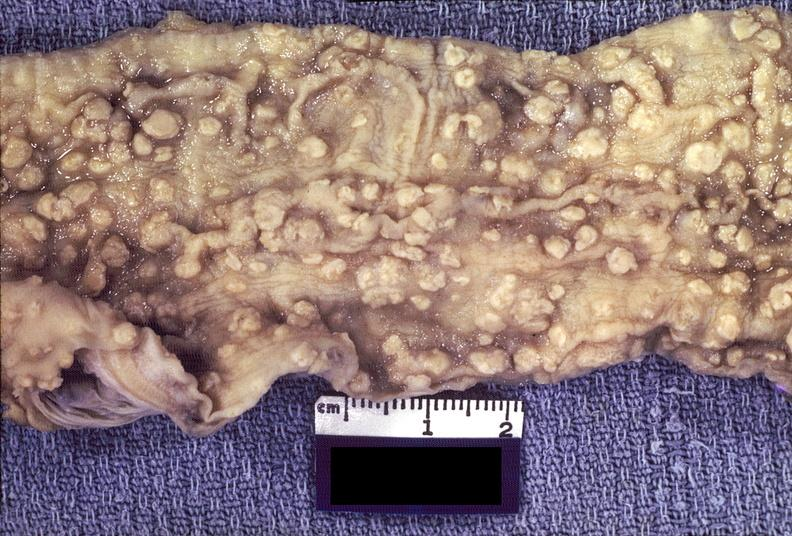s gastrointestinal present?
Answer the question using a single word or phrase. Yes 